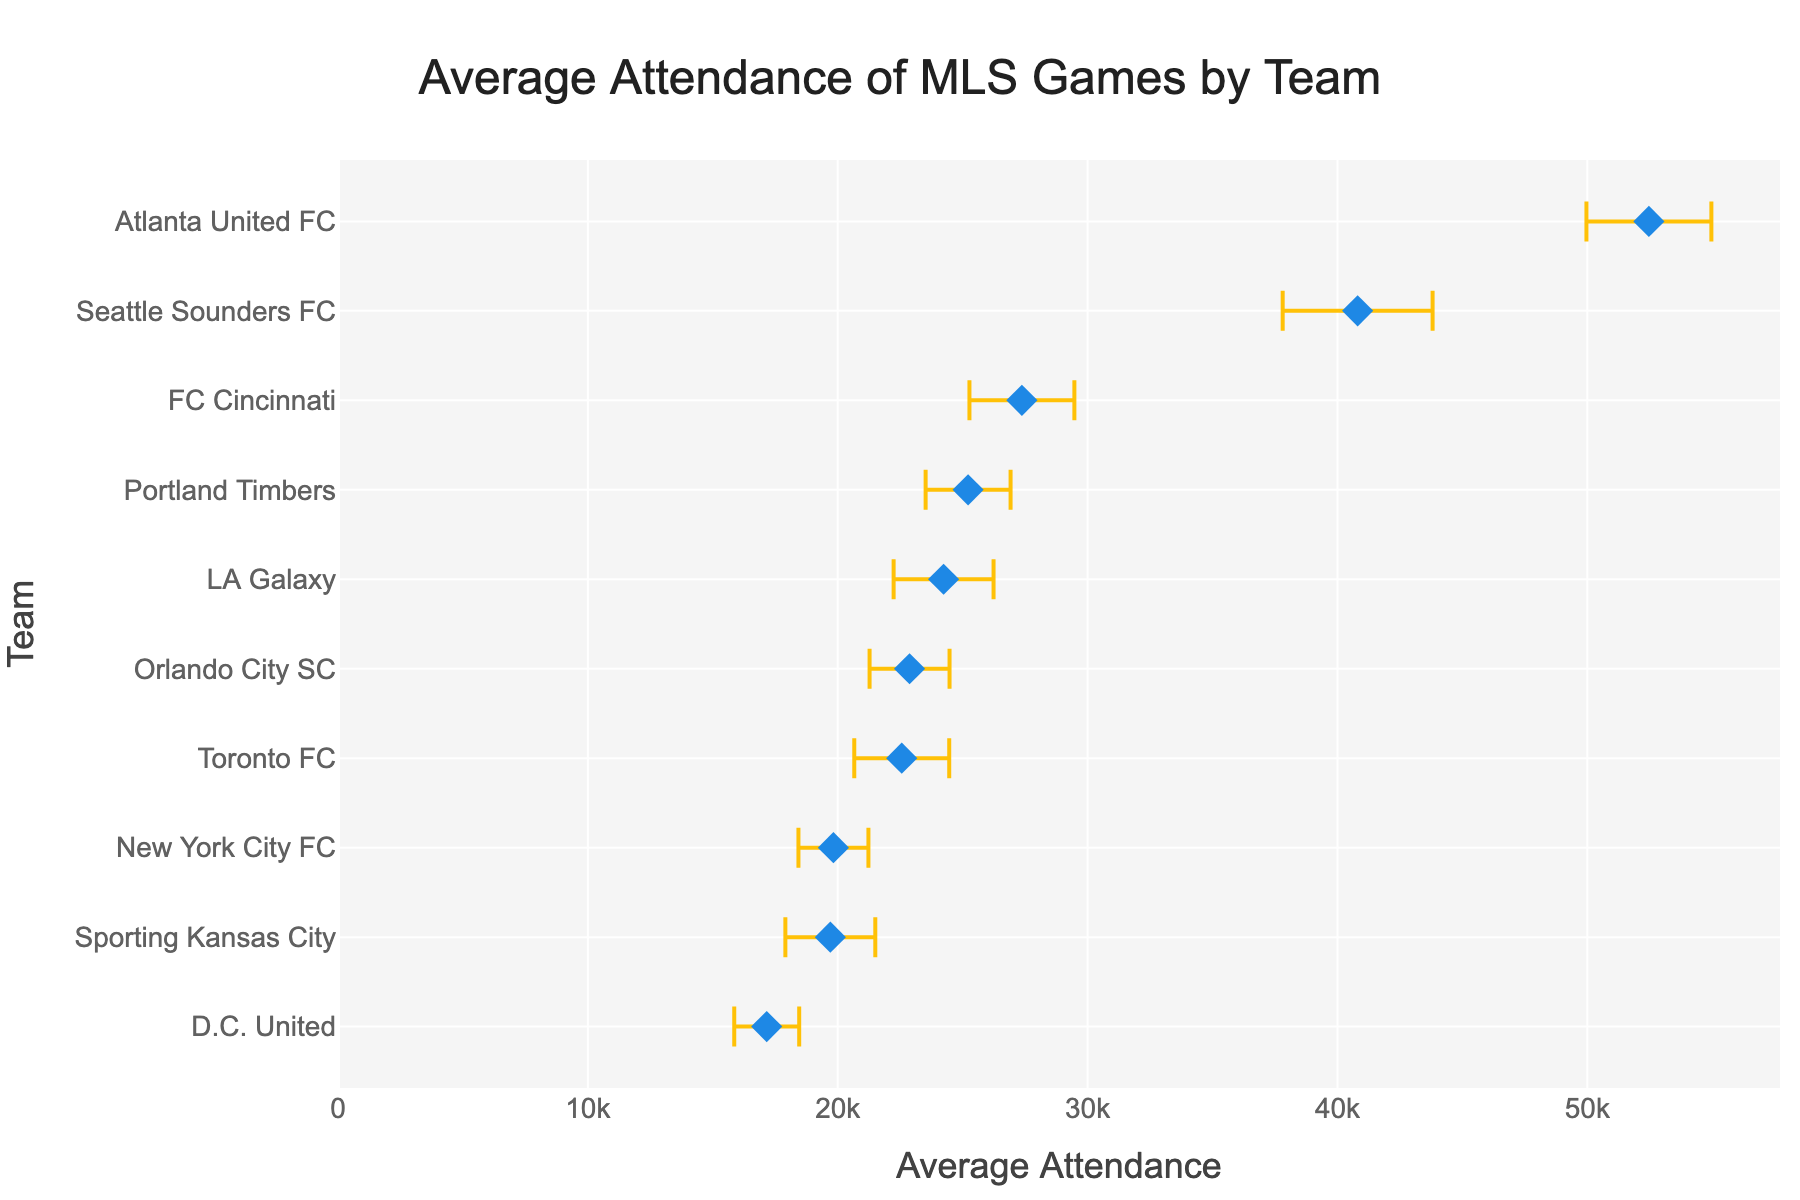What is the title of the plot? The title is displayed at the top of the figure in larger text for easy visibility.
Answer: Average Attendance of MLS Games by Team Which team has the highest average attendance? Look for the data point on the X-axis furthest to the right. The label on the Y-axis associated with this point indicates the team.
Answer: Atlanta United FC How many teams have an average attendance greater than 30,000? Count the number of data points on the X-axis that are positioned to the right of the 30,000 mark.
Answer: 2 What is the average attendance of New York City FC? Locate "New York City FC" on the Y-axis, then find the corresponding point on the X-axis. The X-axis value represents the average attendance for this team.
Answer: 19,828 Which team has the smallest standard deviation in attendance? Identify the error bars represented by the smallest horizontal spread. The label on the Y-axis associated with this point indicates the team.
Answer: D.C. United How does the average attendance of Seattle Sounders FC compare to LA Galaxy? Locate both teams on the Y-axis, then compare their X-axis positions. Determine if Seattle Sounders FC's mark is further right (greater), further left (smaller), or at the same position as LA Galaxy.
Answer: Greater What is the range of the standard deviation for FC Cincinnati? Find the length of the error bar for FC Cincinnati. The standard deviation represents half of the total length of the error bar. Multiply this half-length by 2 to get the full range.
Answer: 2,100 Which team has the larger error bar: Toronto FC or Sporting Kansas City? Compare the horizontal lengths of the error bars for Toronto FC and Sporting Kansas City. The team with the longer error bar has the larger standard deviation.
Answer: Sporting Kansas City By how much does the average attendance of Atlanta United FC exceed that of Portland Timbers? Find the X-axis values for both teams and subtract the value for Portland Timbers from the value for Atlanta United FC.
Answer: 27,247 What is the combined average attendance of the two teams with the highest attendances? Identify the two rightmost data points on the X-axis. Sum the X-axis values of these two points.
Answer: 93,273 